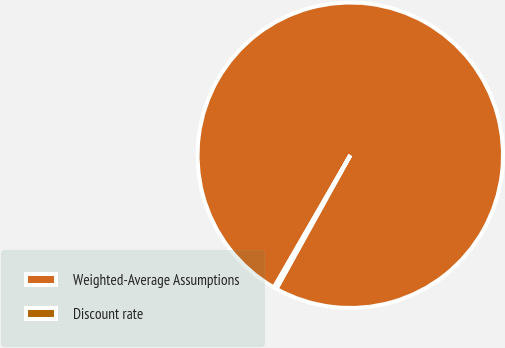Convert chart to OTSL. <chart><loc_0><loc_0><loc_500><loc_500><pie_chart><fcel>Weighted-Average Assumptions<fcel>Discount rate<nl><fcel>99.7%<fcel>0.3%<nl></chart> 